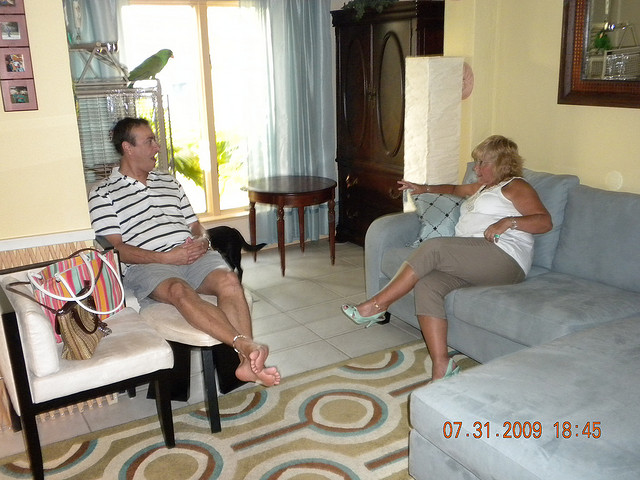Read and extract the text from this image. 07.31.2009 18:45 